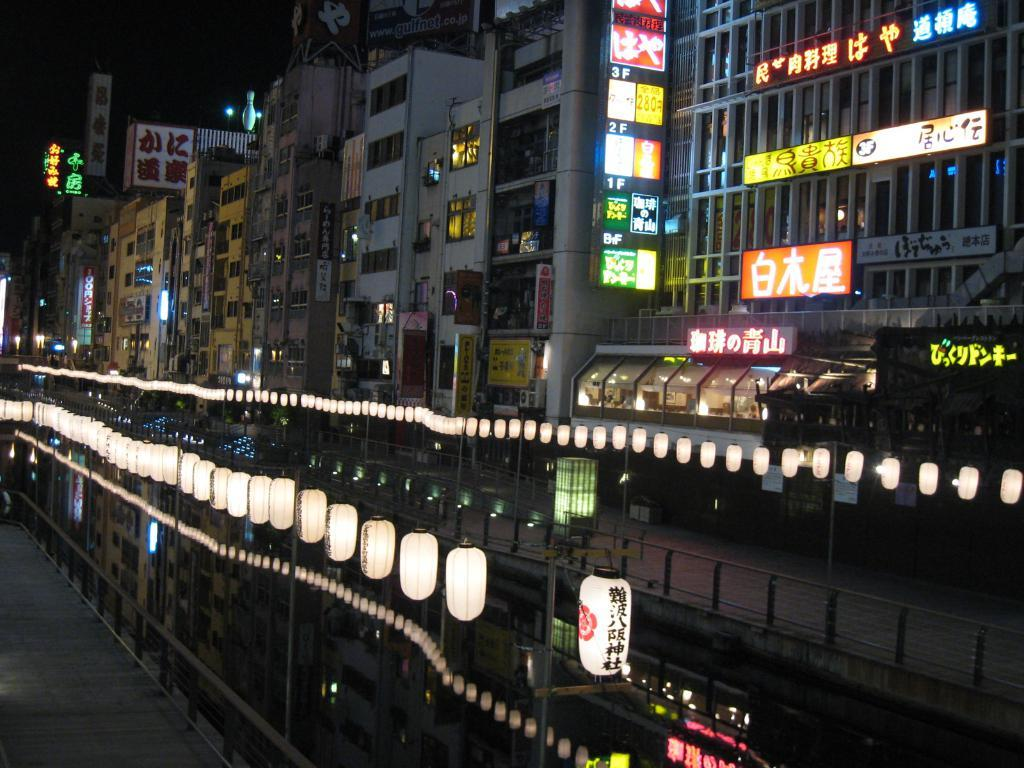What objects in the image emit light? There are lights in the image. What structures are present to support the lights? There are poles in the image. What type of barrier is visible in the image? There is a fence in the image. What material is used to create the boards in the image? The boards in the image are made of a solid material, such as wood or metal. What type of man-made structures can be seen in the image? There are buildings in the image. Can you touch the pets in the image? There are no pets present in the image. What type of room is visible in the image? There is no room visible in the image; it features outdoor structures and objects. 